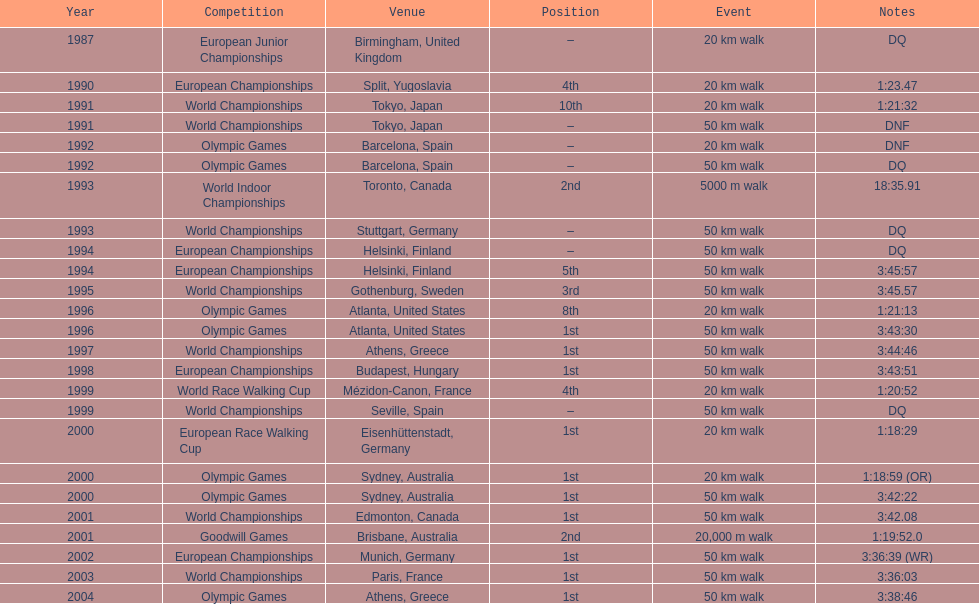In which year did korzeniowski's final contest take place? 2004. 